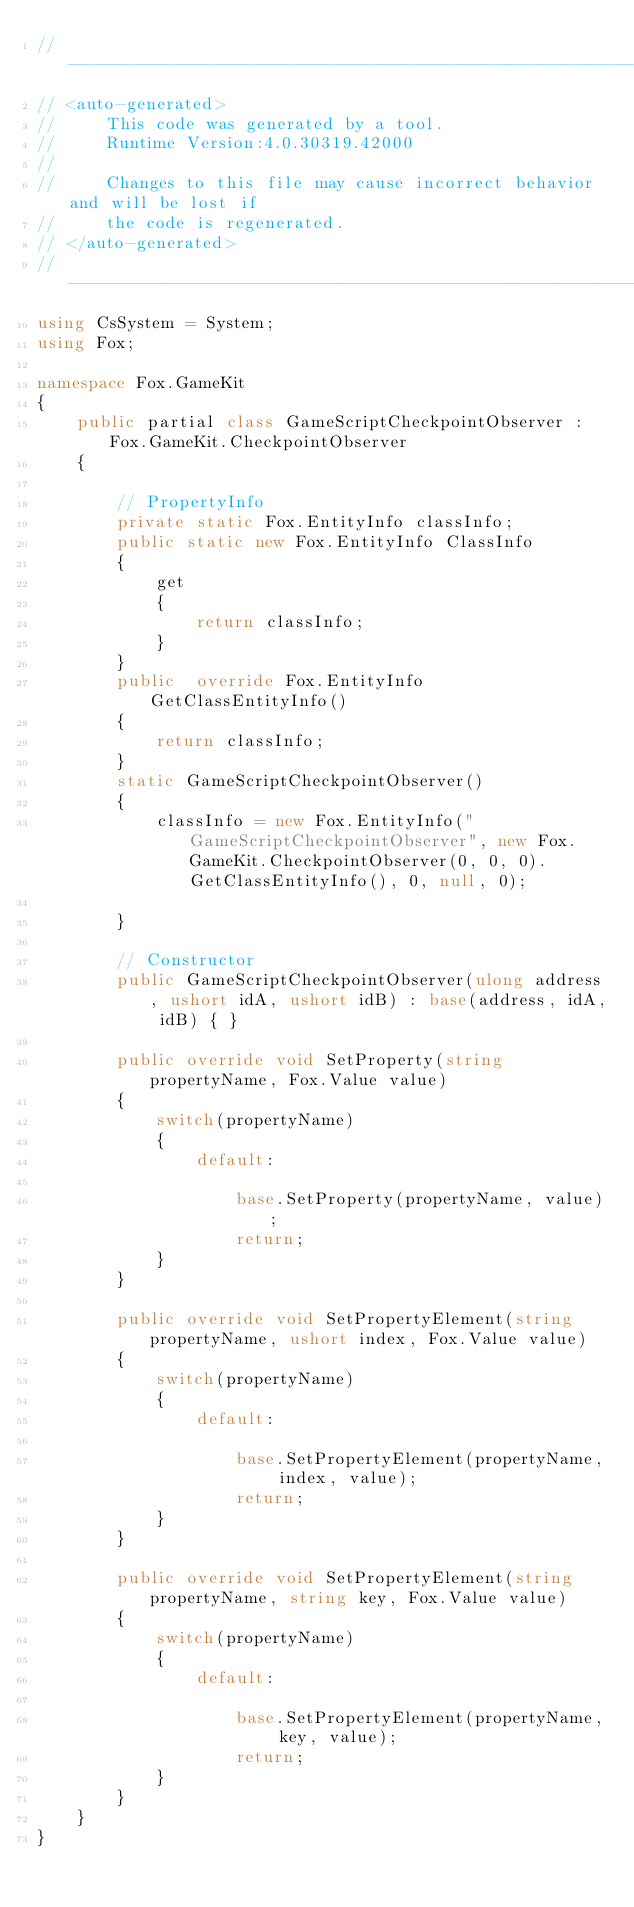Convert code to text. <code><loc_0><loc_0><loc_500><loc_500><_C#_>//------------------------------------------------------------------------------
// <auto-generated>
//     This code was generated by a tool.
//     Runtime Version:4.0.30319.42000
//
//     Changes to this file may cause incorrect behavior and will be lost if
//     the code is regenerated.
// </auto-generated>
//------------------------------------------------------------------------------
using CsSystem = System;
using Fox;

namespace Fox.GameKit
{
    public partial class GameScriptCheckpointObserver : Fox.GameKit.CheckpointObserver 
    {
        
        // PropertyInfo
        private static Fox.EntityInfo classInfo;
        public static new Fox.EntityInfo ClassInfo
        {
            get
            {
                return classInfo;
            }
        }
        public  override Fox.EntityInfo GetClassEntityInfo()
        {
            return classInfo;
        }
        static GameScriptCheckpointObserver()
        {
            classInfo = new Fox.EntityInfo("GameScriptCheckpointObserver", new Fox.GameKit.CheckpointObserver(0, 0, 0).GetClassEntityInfo(), 0, null, 0);
			
        }

        // Constructor
		public GameScriptCheckpointObserver(ulong address, ushort idA, ushort idB) : base(address, idA, idB) { }
        
        public override void SetProperty(string propertyName, Fox.Value value)
        {
            switch(propertyName)
            {
                default:
				    
                    base.SetProperty(propertyName, value);
                    return;
            }
        }
        
        public override void SetPropertyElement(string propertyName, ushort index, Fox.Value value)
        {
            switch(propertyName)
            {
                default:
					
                    base.SetPropertyElement(propertyName, index, value);
                    return;
            }
        }
        
        public override void SetPropertyElement(string propertyName, string key, Fox.Value value)
        {
            switch(propertyName)
            {
                default:
					
                    base.SetPropertyElement(propertyName, key, value);
                    return;
            }
        }
    }
}</code> 